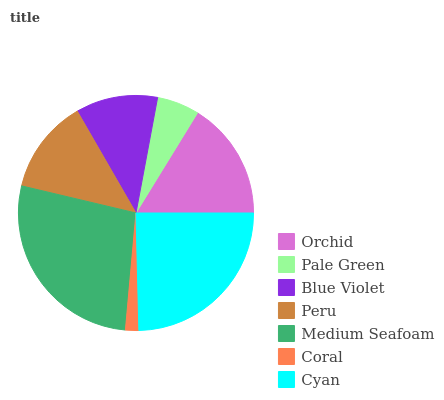Is Coral the minimum?
Answer yes or no. Yes. Is Medium Seafoam the maximum?
Answer yes or no. Yes. Is Pale Green the minimum?
Answer yes or no. No. Is Pale Green the maximum?
Answer yes or no. No. Is Orchid greater than Pale Green?
Answer yes or no. Yes. Is Pale Green less than Orchid?
Answer yes or no. Yes. Is Pale Green greater than Orchid?
Answer yes or no. No. Is Orchid less than Pale Green?
Answer yes or no. No. Is Peru the high median?
Answer yes or no. Yes. Is Peru the low median?
Answer yes or no. Yes. Is Medium Seafoam the high median?
Answer yes or no. No. Is Pale Green the low median?
Answer yes or no. No. 